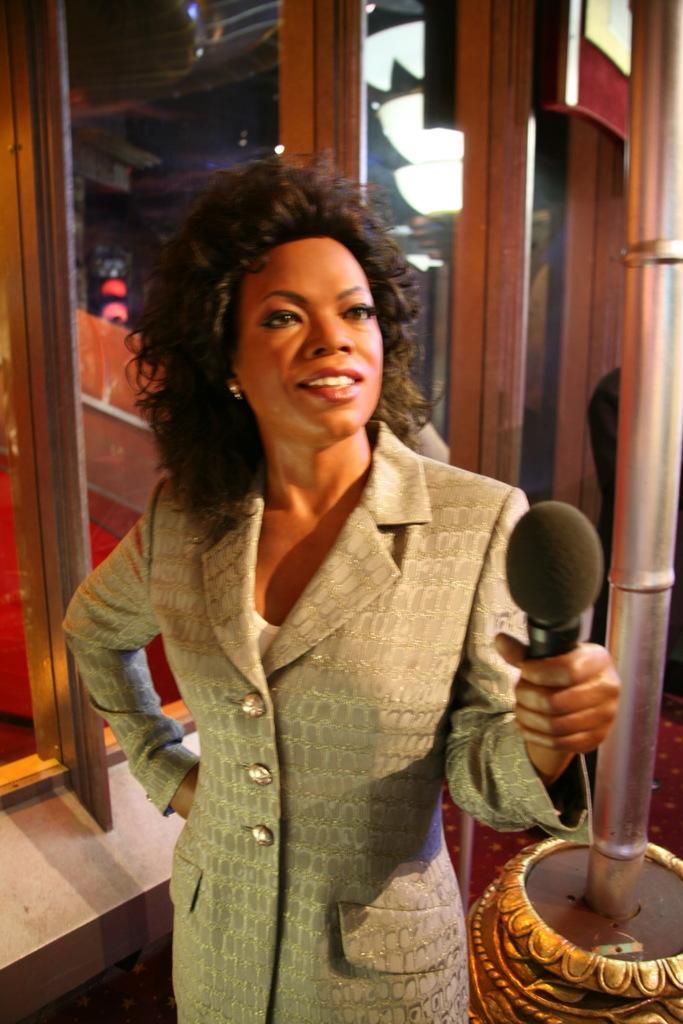What is the main subject of the image? The main subject of the image is a statue of a lady. What is the lady wearing in the image? The lady is wearing a jacket in the image. What is the lady holding in the image? The lady is holding a mic in the image. What can be seen beside the statue in the image? There is a pole beside the statue in the image. What is visible behind the statue in the image? There are glass doors behind the statue in the image. What type of punishment is the lady receiving in the image? There is no indication of punishment in the image; it features a statue of a lady holding a mic. Is the lady in the image experiencing sleet while holding the mic? The image does not provide information about the weather, so it cannot be determined if the lady is experiencing sleet. 